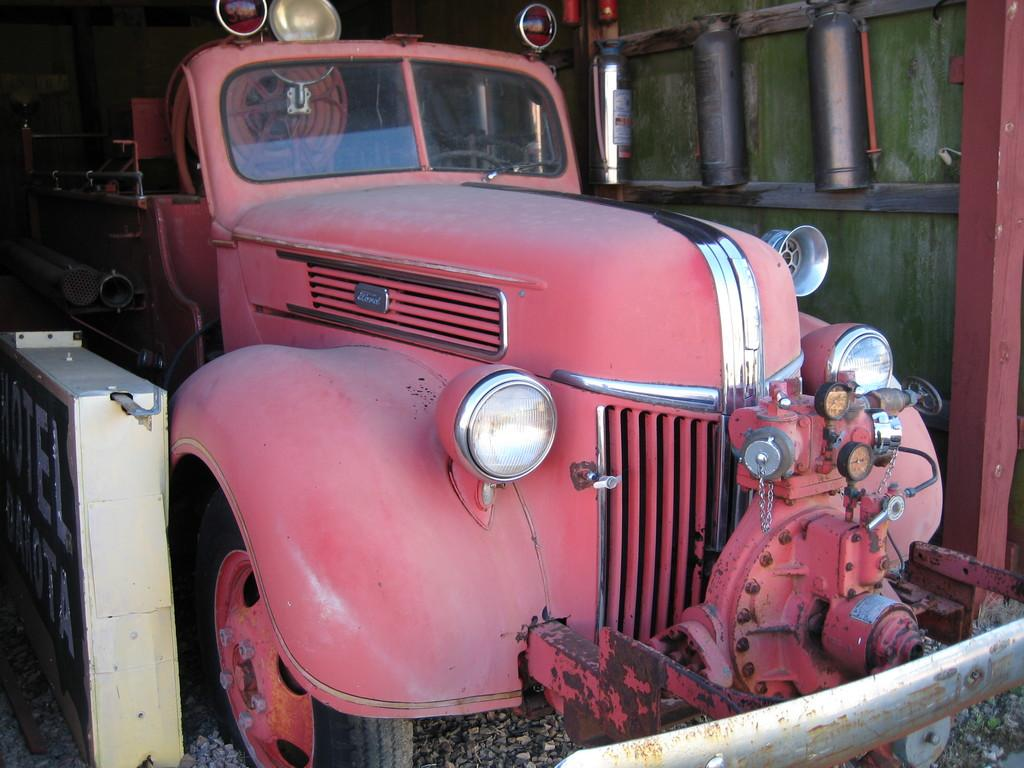What type of motor vehicle is in the image? The specific type of motor vehicle is not mentioned, but it is present in the image. How is the motor vehicle positioned in the image? The motor vehicle is placed on the ground. What can be seen near the motor vehicle? Stones are present near the motor vehicle. What safety equipment is visible in the image? Fire extinguishers are attached to the wall in the image. Reasoning: Let's think step by step by step in order to produce the conversation. We start by identifying the main subject in the image, which is the motor vehicle. Then, we describe its position and the surrounding environment, including the presence of stones. Finally, we mention a safety feature that is visible in the image, which are the fire extinguishers attached to the wall. Each question is designed to elicit a specific detail about the image that is known from the provided facts. Absurd Question/Answer: What type of celery is being cooked in the image? There is no celery or cooking activity present in the image. What type of skirt is the person wearing in the image? There is no person or skirt present in the image. 